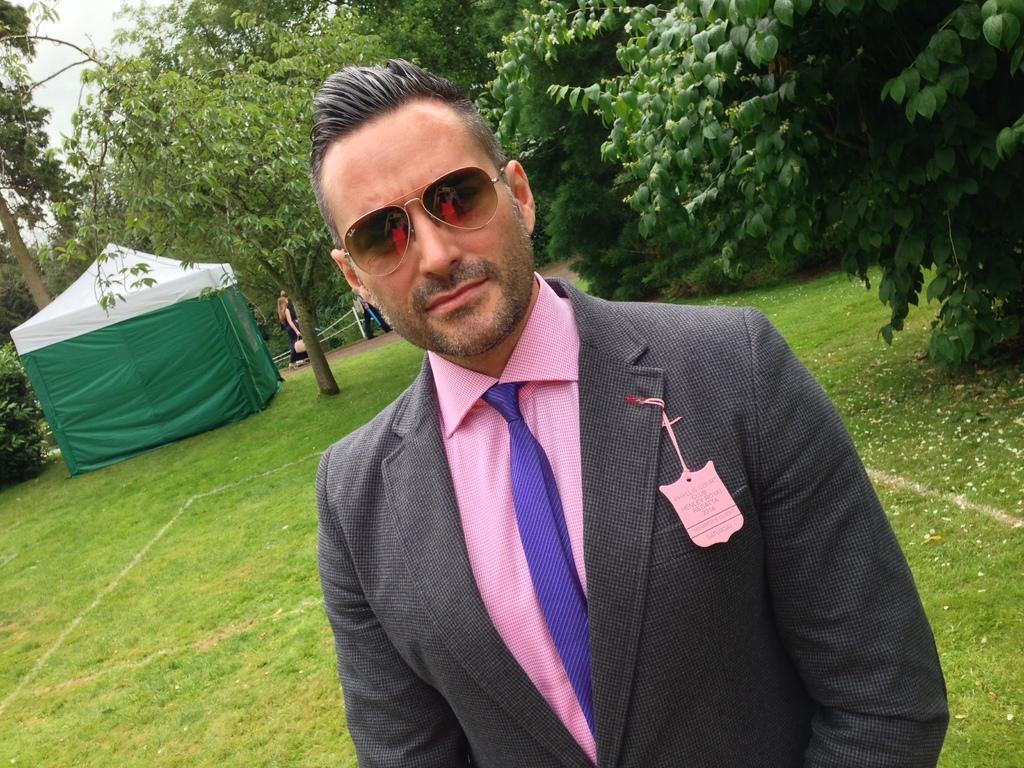Please provide a concise description of this image. In front of the picture, we see a man in the grey blazer and the pink shirt is standing. We see a pink color tag with some text written. He is wearing the goggles and he is posing for the photo. At the bottom, we see the grass. On the right side, we see the trees. On the left side, we see a tent in white and green color. Beside that, we see the people are walking. There are trees in the background. 